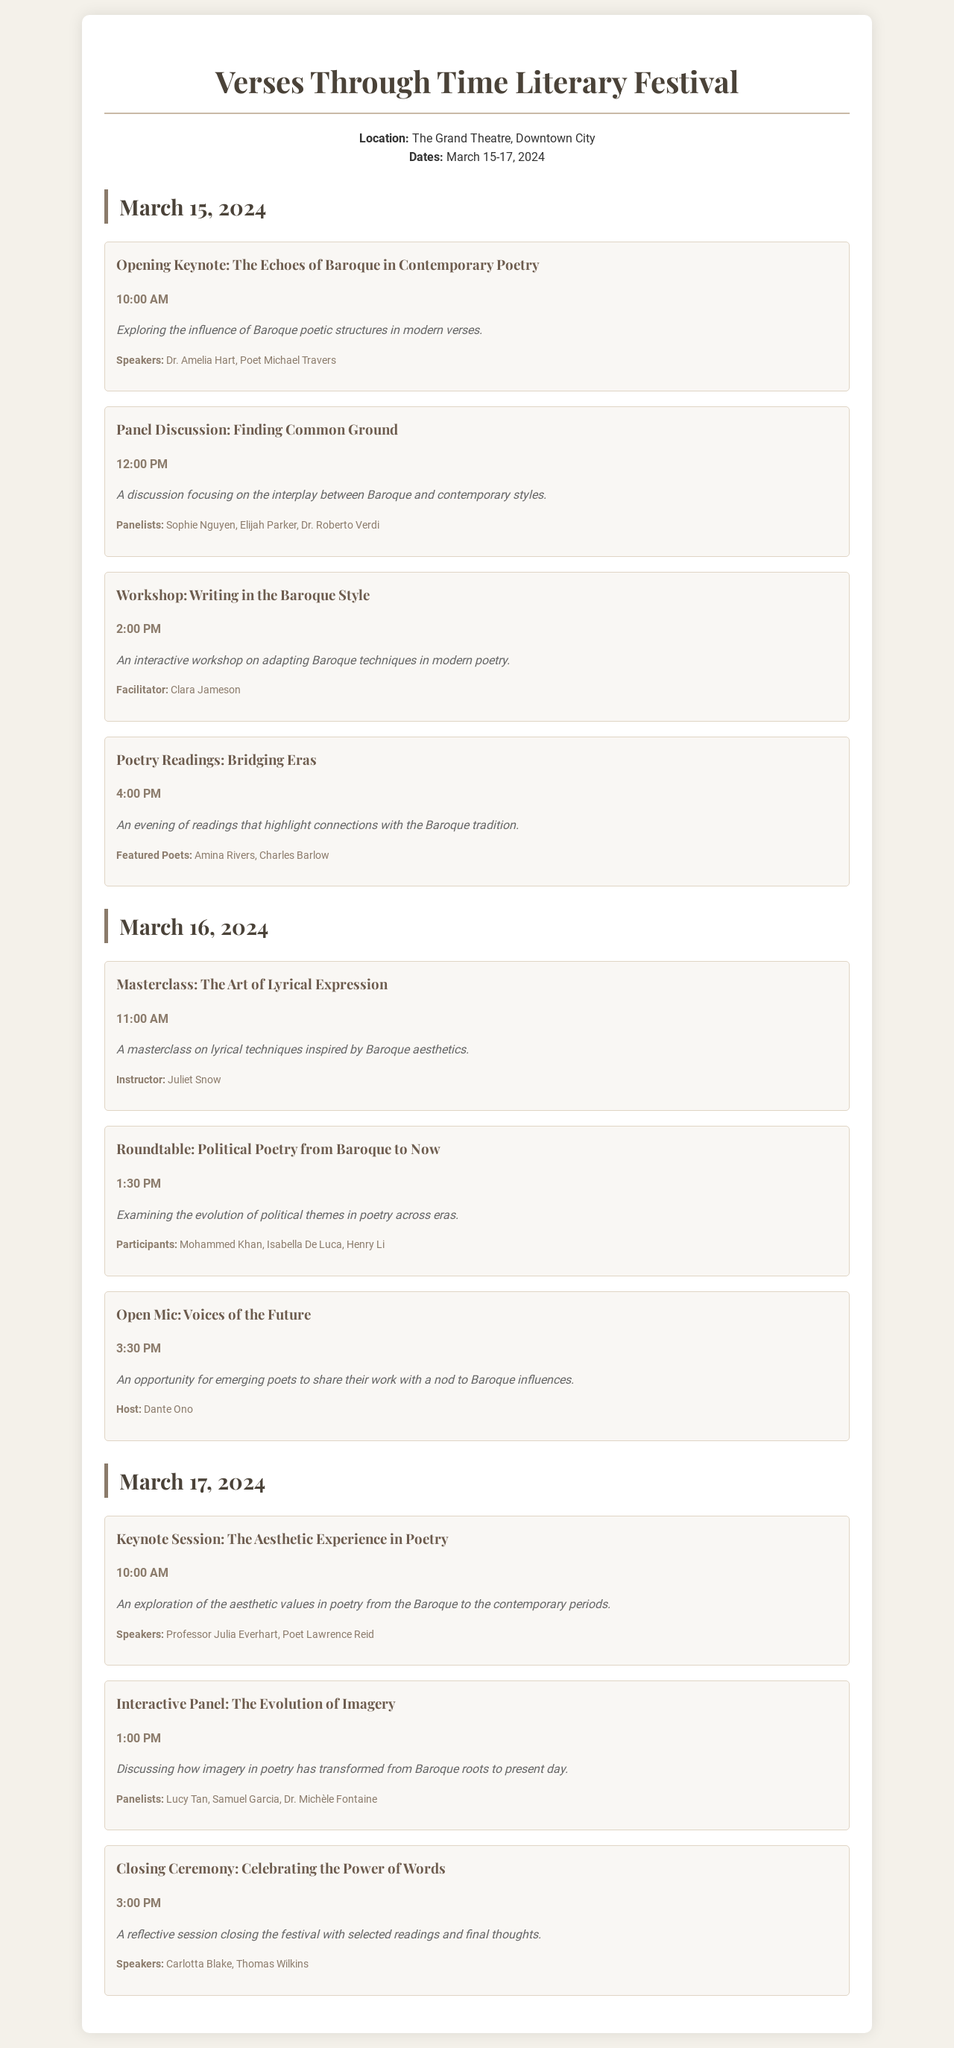What is the name of the literary festival? The name of the literary festival is mentioned clearly at the top of the document.
Answer: Verses Through Time Literary Festival Where is the festival being held? The location of the festival is specified in the document, providing the venue name.
Answer: The Grand Theatre What are the dates of the festival? The document outlines the specific dates over which the festival will take place.
Answer: March 15-17, 2024 Who is the facilitator of the workshop on Baroque writing? The specific individual leading the workshop is listed in the event description.
Answer: Clara Jameson What time does the opening keynote start? The time for the opening keynote is provided within the event details.
Answer: 10:00 AM How many poets are featured in the Poetry Readings event? The number of featured poets can be counted from the attendees listed for the event.
Answer: Two What is the main theme of the panel discussion titled "Finding Common Ground"? The central theme of the panel discussion highlights a specific literary relationship.
Answer: The interplay between Baroque and contemporary styles Which event focuses on political themes in poetry? The document indicates an event dedicated to discussing the evolution of political themes.
Answer: Roundtable: Political Poetry from Baroque to Now What time is the closing ceremony scheduled? The closing ceremony's scheduled time is stated among the events in the document.
Answer: 3:00 PM 